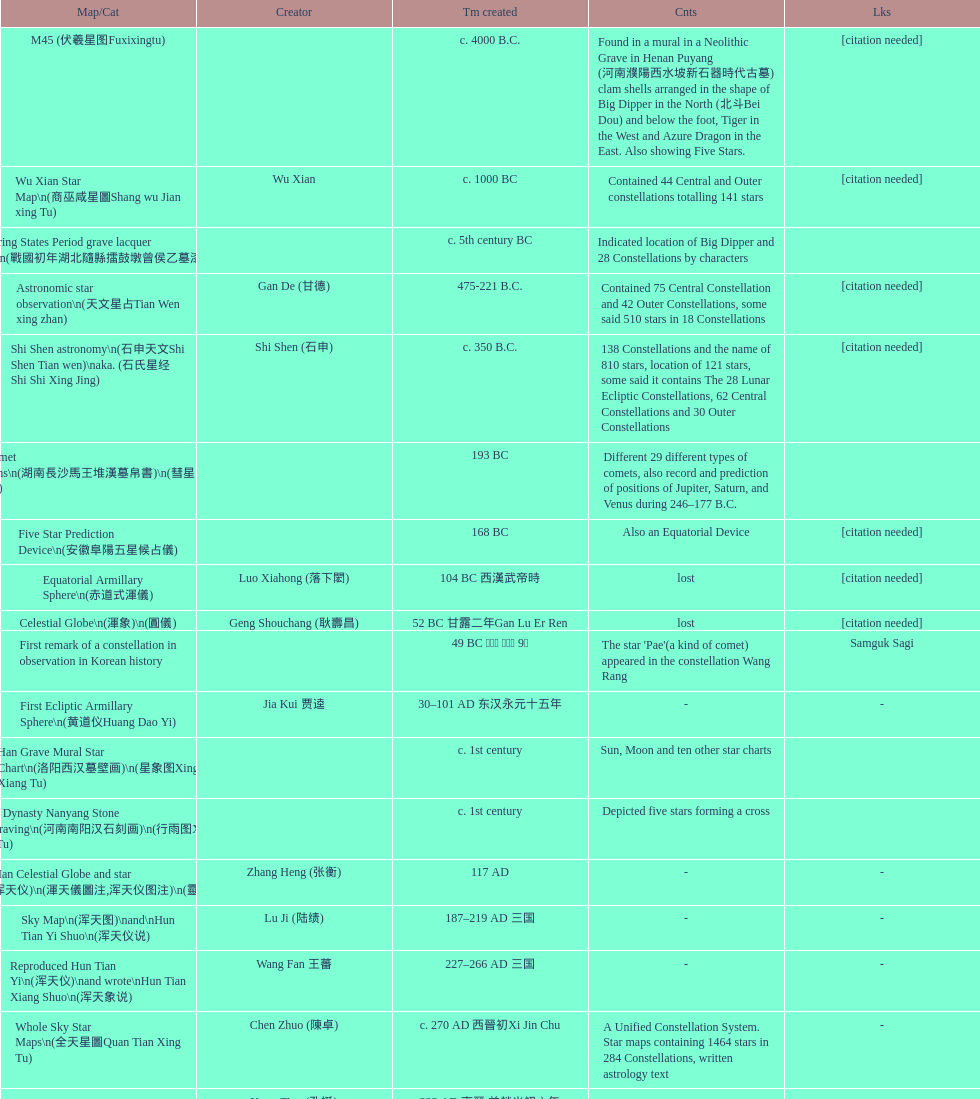Which map or catalog was created last? Sky in Google Earth KML. 